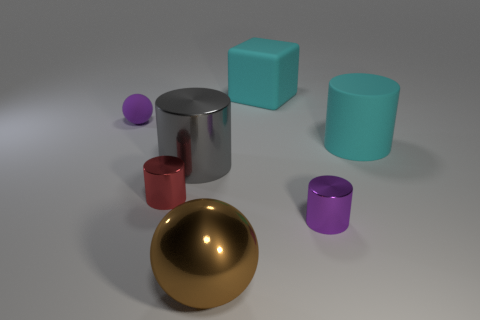Subtract all red cylinders. How many cylinders are left? 3 Subtract all gray cylinders. How many cylinders are left? 3 Subtract all brown cylinders. Subtract all yellow balls. How many cylinders are left? 4 Add 2 tiny things. How many objects exist? 9 Subtract all blocks. How many objects are left? 6 Subtract all large cyan cylinders. Subtract all small balls. How many objects are left? 5 Add 1 rubber balls. How many rubber balls are left? 2 Add 1 rubber things. How many rubber things exist? 4 Subtract 1 purple balls. How many objects are left? 6 